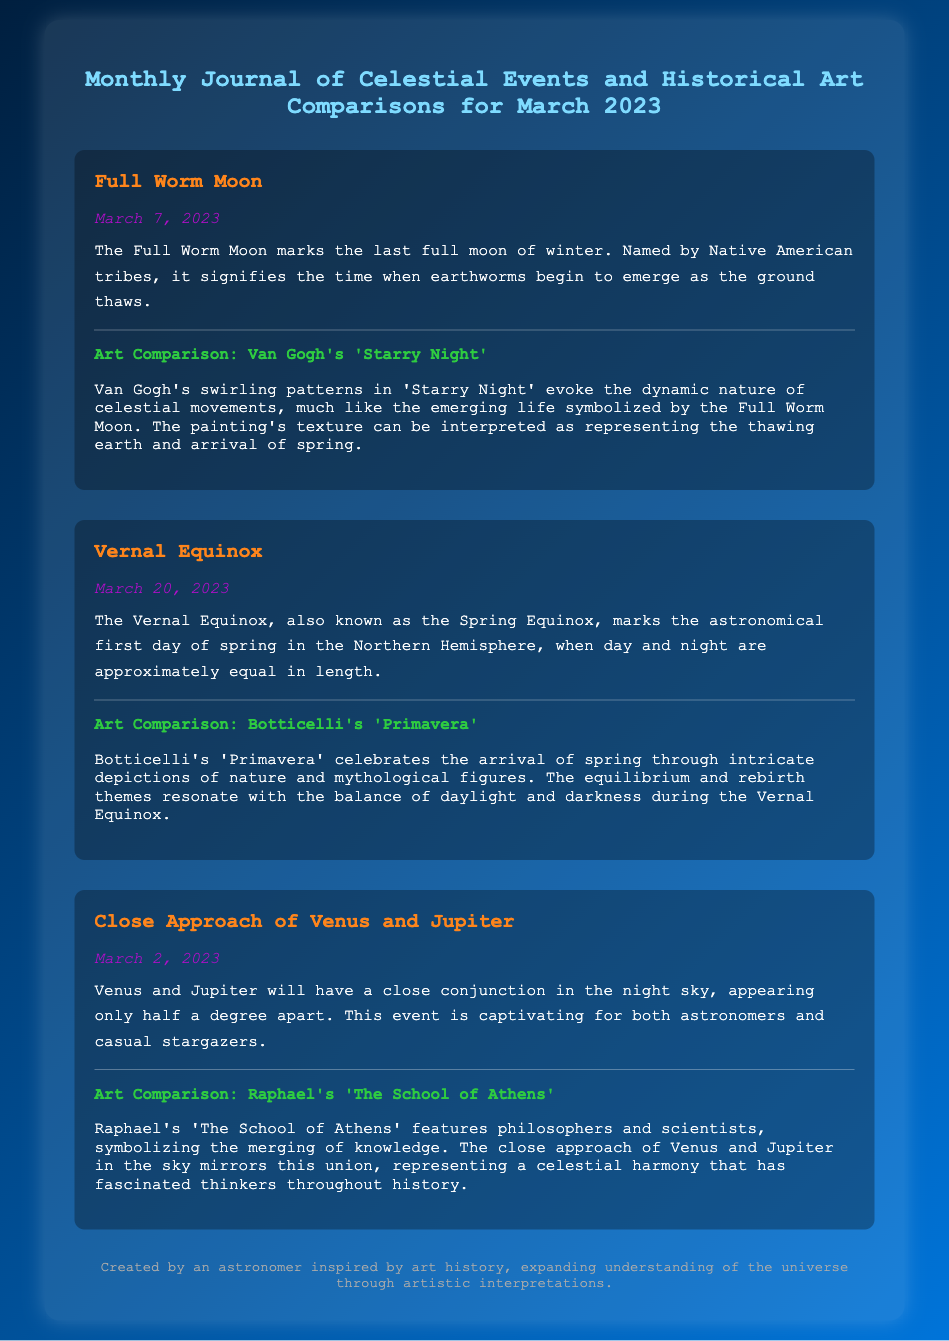What is the name of the full moon in March 2023? The document states that the full moon in March 2023 is called the Full Worm Moon.
Answer: Full Worm Moon On what date does the Vernal Equinox occur? The document mentions that the Vernal Equinox occurs on March 20, 2023.
Answer: March 20, 2023 Which two planets have a close approach in March 2023? According to the document, Venus and Jupiter have a close approach in March 2023.
Answer: Venus and Jupiter What is the title of Van Gogh's artwork compared to the Full Worm Moon? The document states that the artwork compared to the Full Worm Moon is Van Gogh's 'Starry Night'.
Answer: 'Starry Night' What theme does Botticelli's 'Primavera' represent in relation to the Vernal Equinox? The document explains that Botticelli's 'Primavera' represents equilibrium and rebirth, resonating with the balance of daylight and darkness during the Vernal Equinox.
Answer: Equilibrium and rebirth How is the close approach of Venus and Jupiter symbolically represented in the art of Raphael? The document indicates that Raphael's 'The School of Athens' symbolizes the merging of knowledge, similar to the close approach of Venus and Jupiter.
Answer: Merging of knowledge What natural event does the Full Worm Moon signify? The document describes the Full Worm Moon as signifying the time when earthworms begin to emerge as the ground thaws.
Answer: Emergence of earthworms What artistic method does Van Gogh use to represent celestial movements? According to the document, Van Gogh uses swirling patterns in 'Starry Night' to evoke the dynamic nature of celestial movements.
Answer: Swirling patterns 